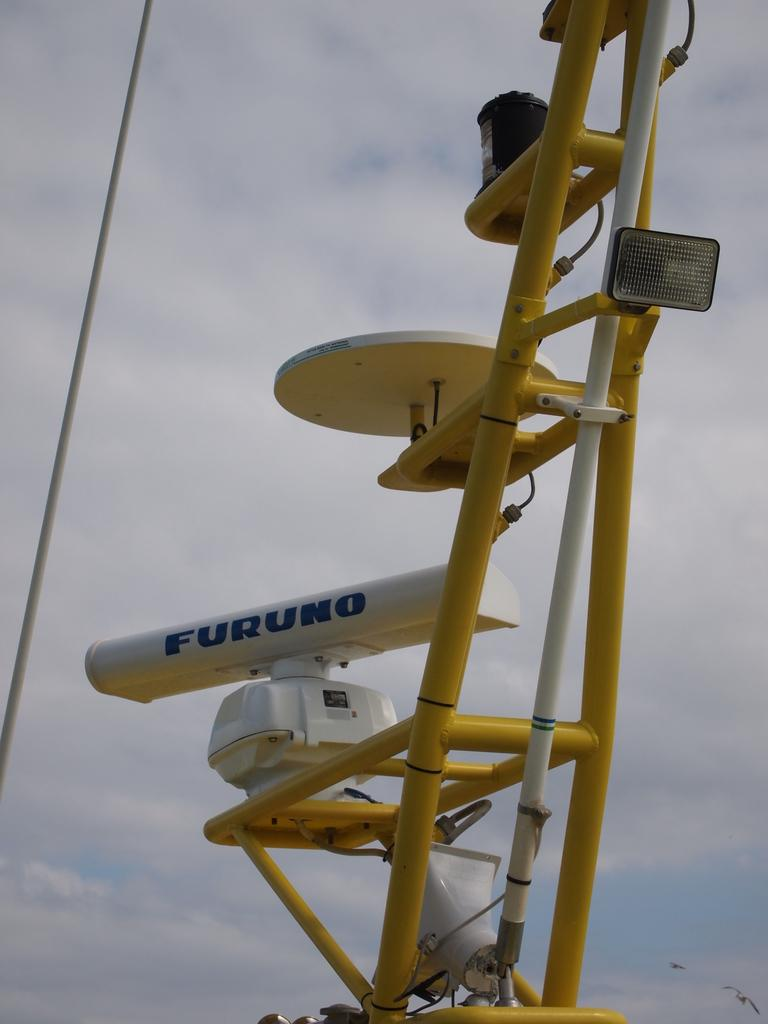What is the main subject of the image? The main subject of the image is devices on a metal frame. What can be seen in the background of the image? The sky is visible in the image. How would you describe the sky in the image? The sky appears to be cloudy in the image. What else is happening in the image? Birds are flying in the bottom part of the image. What date is marked on the calendar in the image? There is no calendar present in the image. What type of rail can be seen in the image? There is no rail present in the image. 